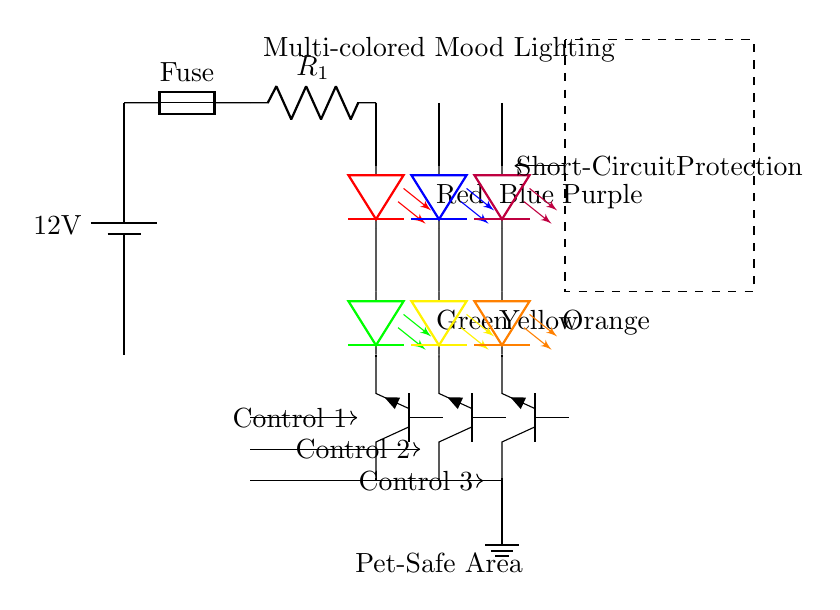What is the voltage of the power supply? The power supply is labeled as 12V in the diagram, indicating it provides a potential difference of twelve volts to the circuit.
Answer: 12V How many LED colors are included in this circuit? The circuit diagram shows six different LED colors: red, green, blue, yellow, purple, and orange, counted directly from the labeled components.
Answer: Six What type of transistor is used in this circuit? The diagram specifies the transistors as NPN types, indicating the configuration of the transistors used for LED control.
Answer: NPN What is the purpose of the fuse in this circuit? The fuse is used for overcurrent protection, which helps to prevent excessive current flow that could damage the circuit components or cause a fire.
Answer: Overcurrent protection Which component is responsible for short-circuit protection? A dashed rectangle labeled "Short-Circuit Protection" indicates the designated area in the circuit for protecting against short circuits.
Answer: Short-Circuit Protection What happens when a short circuit occurs in this lighting system? In the event of a short circuit, the short-circuit protection will interrupt the current flow to prevent damage to the LED strings and other components in the circuit.
Answer: Interrupt current flow What is the role of the current limiting resistor in this circuit? The current limiting resistor is placed in the circuit to limit the amount of current flowing through the LEDs, ensuring they function within their safe operating limits.
Answer: Limit current flow 